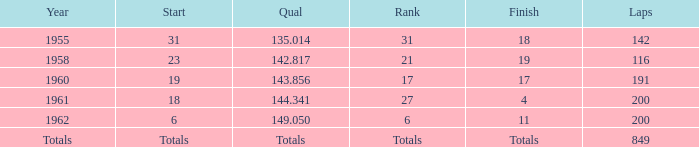Parse the table in full. {'header': ['Year', 'Start', 'Qual', 'Rank', 'Finish', 'Laps'], 'rows': [['1955', '31', '135.014', '31', '18', '142'], ['1958', '23', '142.817', '21', '19', '116'], ['1960', '19', '143.856', '17', '17', '191'], ['1961', '18', '144.341', '27', '4', '200'], ['1962', '6', '149.050', '6', '11', '200'], ['Totals', 'Totals', 'Totals', 'Totals', 'Totals', '849']]} The year with 116 laps is? 1958.0. 